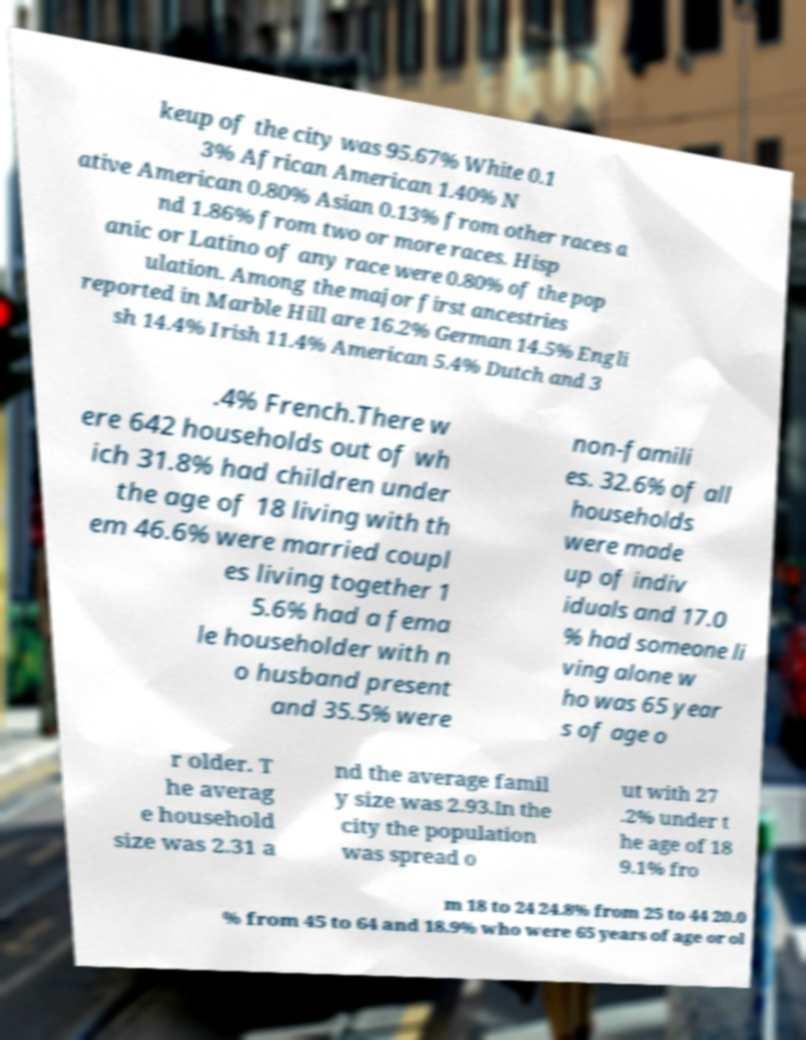For documentation purposes, I need the text within this image transcribed. Could you provide that? keup of the city was 95.67% White 0.1 3% African American 1.40% N ative American 0.80% Asian 0.13% from other races a nd 1.86% from two or more races. Hisp anic or Latino of any race were 0.80% of the pop ulation. Among the major first ancestries reported in Marble Hill are 16.2% German 14.5% Engli sh 14.4% Irish 11.4% American 5.4% Dutch and 3 .4% French.There w ere 642 households out of wh ich 31.8% had children under the age of 18 living with th em 46.6% were married coupl es living together 1 5.6% had a fema le householder with n o husband present and 35.5% were non-famili es. 32.6% of all households were made up of indiv iduals and 17.0 % had someone li ving alone w ho was 65 year s of age o r older. T he averag e household size was 2.31 a nd the average famil y size was 2.93.In the city the population was spread o ut with 27 .2% under t he age of 18 9.1% fro m 18 to 24 24.8% from 25 to 44 20.0 % from 45 to 64 and 18.9% who were 65 years of age or ol 